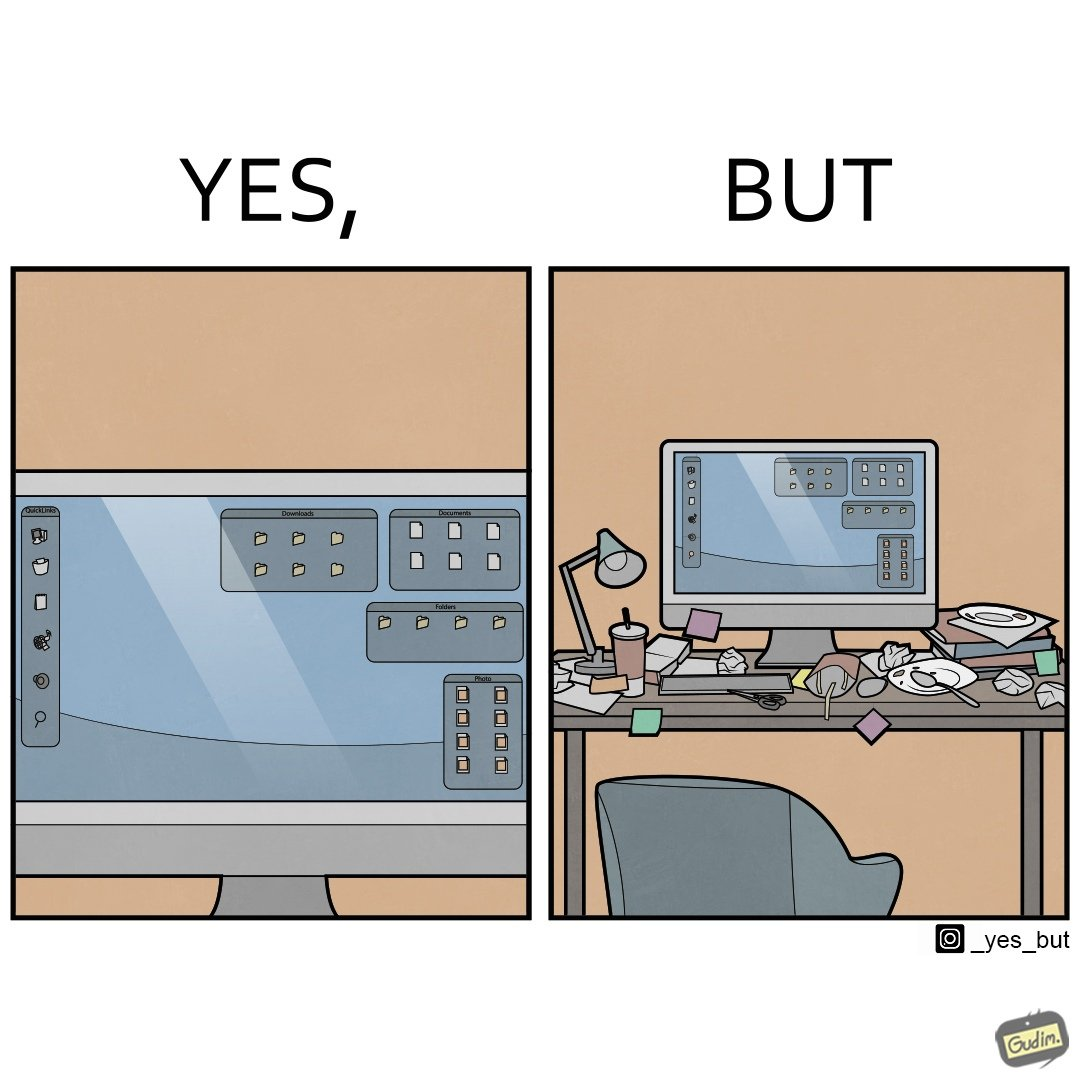What is the satirical meaning behind this image? The image is ironical, as the folder icons on the desktop screen are very neatly arranged, while the person using the computer has littered the table with used food packets, dirty plates, and wrappers. 